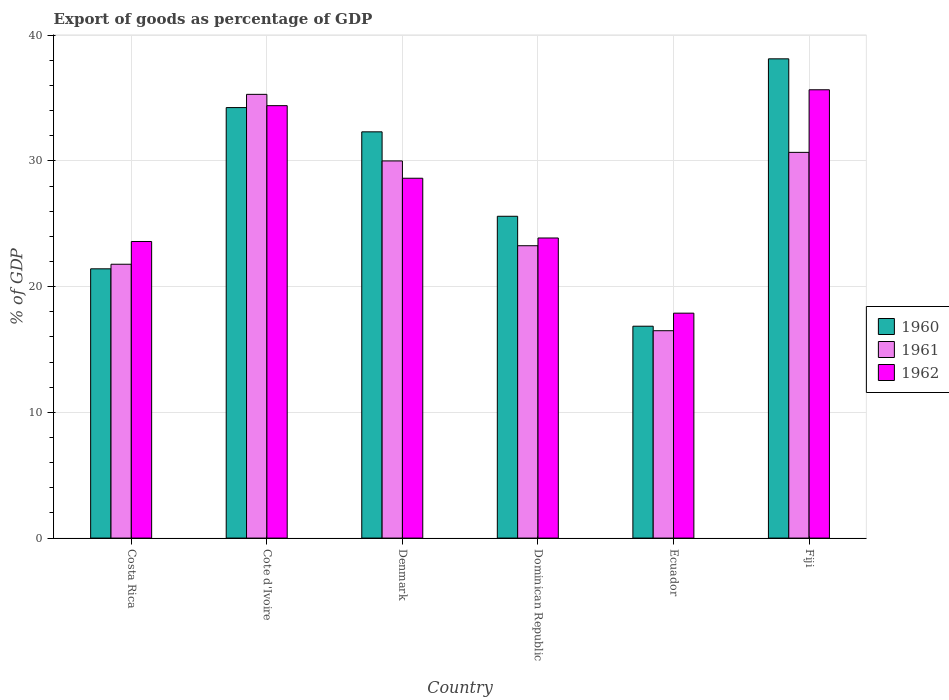How many different coloured bars are there?
Offer a very short reply. 3. Are the number of bars per tick equal to the number of legend labels?
Provide a short and direct response. Yes. Are the number of bars on each tick of the X-axis equal?
Offer a terse response. Yes. How many bars are there on the 4th tick from the left?
Offer a terse response. 3. How many bars are there on the 3rd tick from the right?
Give a very brief answer. 3. What is the label of the 4th group of bars from the left?
Your answer should be very brief. Dominican Republic. What is the export of goods as percentage of GDP in 1961 in Denmark?
Offer a very short reply. 30. Across all countries, what is the maximum export of goods as percentage of GDP in 1962?
Give a very brief answer. 35.66. Across all countries, what is the minimum export of goods as percentage of GDP in 1961?
Your response must be concise. 16.49. In which country was the export of goods as percentage of GDP in 1960 maximum?
Your answer should be very brief. Fiji. In which country was the export of goods as percentage of GDP in 1960 minimum?
Your answer should be compact. Ecuador. What is the total export of goods as percentage of GDP in 1961 in the graph?
Provide a short and direct response. 157.49. What is the difference between the export of goods as percentage of GDP in 1962 in Costa Rica and that in Dominican Republic?
Provide a succinct answer. -0.28. What is the difference between the export of goods as percentage of GDP in 1962 in Ecuador and the export of goods as percentage of GDP in 1961 in Dominican Republic?
Provide a short and direct response. -5.36. What is the average export of goods as percentage of GDP in 1961 per country?
Provide a short and direct response. 26.25. What is the difference between the export of goods as percentage of GDP of/in 1962 and export of goods as percentage of GDP of/in 1960 in Denmark?
Provide a succinct answer. -3.69. In how many countries, is the export of goods as percentage of GDP in 1961 greater than 28 %?
Keep it short and to the point. 3. What is the ratio of the export of goods as percentage of GDP in 1962 in Dominican Republic to that in Ecuador?
Give a very brief answer. 1.33. What is the difference between the highest and the second highest export of goods as percentage of GDP in 1960?
Provide a short and direct response. -1.93. What is the difference between the highest and the lowest export of goods as percentage of GDP in 1960?
Your answer should be very brief. 21.26. What does the 1st bar from the left in Ecuador represents?
Provide a short and direct response. 1960. What does the 1st bar from the right in Denmark represents?
Keep it short and to the point. 1962. Are all the bars in the graph horizontal?
Your answer should be very brief. No. How many countries are there in the graph?
Your response must be concise. 6. Are the values on the major ticks of Y-axis written in scientific E-notation?
Keep it short and to the point. No. Does the graph contain grids?
Offer a very short reply. Yes. Where does the legend appear in the graph?
Offer a very short reply. Center right. How are the legend labels stacked?
Your answer should be compact. Vertical. What is the title of the graph?
Offer a very short reply. Export of goods as percentage of GDP. What is the label or title of the X-axis?
Provide a short and direct response. Country. What is the label or title of the Y-axis?
Offer a terse response. % of GDP. What is the % of GDP of 1960 in Costa Rica?
Your response must be concise. 21.42. What is the % of GDP in 1961 in Costa Rica?
Provide a short and direct response. 21.78. What is the % of GDP in 1962 in Costa Rica?
Your answer should be very brief. 23.59. What is the % of GDP of 1960 in Cote d'Ivoire?
Your answer should be compact. 34.24. What is the % of GDP of 1961 in Cote d'Ivoire?
Keep it short and to the point. 35.29. What is the % of GDP of 1962 in Cote d'Ivoire?
Keep it short and to the point. 34.39. What is the % of GDP of 1960 in Denmark?
Your answer should be compact. 32.31. What is the % of GDP of 1961 in Denmark?
Offer a very short reply. 30. What is the % of GDP in 1962 in Denmark?
Make the answer very short. 28.62. What is the % of GDP of 1960 in Dominican Republic?
Offer a terse response. 25.59. What is the % of GDP of 1961 in Dominican Republic?
Provide a succinct answer. 23.25. What is the % of GDP in 1962 in Dominican Republic?
Your answer should be very brief. 23.87. What is the % of GDP in 1960 in Ecuador?
Offer a terse response. 16.85. What is the % of GDP of 1961 in Ecuador?
Keep it short and to the point. 16.49. What is the % of GDP of 1962 in Ecuador?
Your answer should be compact. 17.89. What is the % of GDP of 1960 in Fiji?
Give a very brief answer. 38.12. What is the % of GDP in 1961 in Fiji?
Your answer should be compact. 30.68. What is the % of GDP in 1962 in Fiji?
Provide a short and direct response. 35.66. Across all countries, what is the maximum % of GDP of 1960?
Make the answer very short. 38.12. Across all countries, what is the maximum % of GDP in 1961?
Your answer should be compact. 35.29. Across all countries, what is the maximum % of GDP in 1962?
Make the answer very short. 35.66. Across all countries, what is the minimum % of GDP in 1960?
Provide a short and direct response. 16.85. Across all countries, what is the minimum % of GDP in 1961?
Your answer should be compact. 16.49. Across all countries, what is the minimum % of GDP in 1962?
Offer a very short reply. 17.89. What is the total % of GDP in 1960 in the graph?
Your answer should be compact. 168.53. What is the total % of GDP in 1961 in the graph?
Your answer should be compact. 157.49. What is the total % of GDP of 1962 in the graph?
Offer a very short reply. 164.02. What is the difference between the % of GDP of 1960 in Costa Rica and that in Cote d'Ivoire?
Offer a terse response. -12.82. What is the difference between the % of GDP in 1961 in Costa Rica and that in Cote d'Ivoire?
Keep it short and to the point. -13.51. What is the difference between the % of GDP of 1962 in Costa Rica and that in Cote d'Ivoire?
Give a very brief answer. -10.8. What is the difference between the % of GDP in 1960 in Costa Rica and that in Denmark?
Provide a succinct answer. -10.89. What is the difference between the % of GDP in 1961 in Costa Rica and that in Denmark?
Keep it short and to the point. -8.22. What is the difference between the % of GDP of 1962 in Costa Rica and that in Denmark?
Offer a very short reply. -5.03. What is the difference between the % of GDP in 1960 in Costa Rica and that in Dominican Republic?
Provide a short and direct response. -4.18. What is the difference between the % of GDP of 1961 in Costa Rica and that in Dominican Republic?
Provide a short and direct response. -1.47. What is the difference between the % of GDP of 1962 in Costa Rica and that in Dominican Republic?
Provide a succinct answer. -0.28. What is the difference between the % of GDP in 1960 in Costa Rica and that in Ecuador?
Ensure brevity in your answer.  4.56. What is the difference between the % of GDP of 1961 in Costa Rica and that in Ecuador?
Offer a very short reply. 5.29. What is the difference between the % of GDP in 1962 in Costa Rica and that in Ecuador?
Provide a succinct answer. 5.7. What is the difference between the % of GDP in 1960 in Costa Rica and that in Fiji?
Give a very brief answer. -16.7. What is the difference between the % of GDP of 1961 in Costa Rica and that in Fiji?
Your answer should be very brief. -8.9. What is the difference between the % of GDP in 1962 in Costa Rica and that in Fiji?
Provide a succinct answer. -12.07. What is the difference between the % of GDP in 1960 in Cote d'Ivoire and that in Denmark?
Ensure brevity in your answer.  1.93. What is the difference between the % of GDP of 1961 in Cote d'Ivoire and that in Denmark?
Your response must be concise. 5.3. What is the difference between the % of GDP of 1962 in Cote d'Ivoire and that in Denmark?
Make the answer very short. 5.77. What is the difference between the % of GDP of 1960 in Cote d'Ivoire and that in Dominican Republic?
Your answer should be very brief. 8.64. What is the difference between the % of GDP in 1961 in Cote d'Ivoire and that in Dominican Republic?
Your answer should be compact. 12.04. What is the difference between the % of GDP in 1962 in Cote d'Ivoire and that in Dominican Republic?
Ensure brevity in your answer.  10.52. What is the difference between the % of GDP of 1960 in Cote d'Ivoire and that in Ecuador?
Offer a terse response. 17.39. What is the difference between the % of GDP of 1961 in Cote d'Ivoire and that in Ecuador?
Keep it short and to the point. 18.8. What is the difference between the % of GDP in 1962 in Cote d'Ivoire and that in Ecuador?
Offer a very short reply. 16.5. What is the difference between the % of GDP of 1960 in Cote d'Ivoire and that in Fiji?
Ensure brevity in your answer.  -3.88. What is the difference between the % of GDP in 1961 in Cote d'Ivoire and that in Fiji?
Your answer should be very brief. 4.61. What is the difference between the % of GDP in 1962 in Cote d'Ivoire and that in Fiji?
Give a very brief answer. -1.26. What is the difference between the % of GDP in 1960 in Denmark and that in Dominican Republic?
Provide a succinct answer. 6.72. What is the difference between the % of GDP in 1961 in Denmark and that in Dominican Republic?
Your answer should be very brief. 6.74. What is the difference between the % of GDP in 1962 in Denmark and that in Dominican Republic?
Ensure brevity in your answer.  4.75. What is the difference between the % of GDP in 1960 in Denmark and that in Ecuador?
Your answer should be compact. 15.46. What is the difference between the % of GDP of 1961 in Denmark and that in Ecuador?
Give a very brief answer. 13.5. What is the difference between the % of GDP in 1962 in Denmark and that in Ecuador?
Make the answer very short. 10.73. What is the difference between the % of GDP of 1960 in Denmark and that in Fiji?
Your response must be concise. -5.81. What is the difference between the % of GDP in 1961 in Denmark and that in Fiji?
Give a very brief answer. -0.68. What is the difference between the % of GDP in 1962 in Denmark and that in Fiji?
Offer a very short reply. -7.04. What is the difference between the % of GDP in 1960 in Dominican Republic and that in Ecuador?
Offer a terse response. 8.74. What is the difference between the % of GDP of 1961 in Dominican Republic and that in Ecuador?
Ensure brevity in your answer.  6.76. What is the difference between the % of GDP in 1962 in Dominican Republic and that in Ecuador?
Your response must be concise. 5.98. What is the difference between the % of GDP of 1960 in Dominican Republic and that in Fiji?
Ensure brevity in your answer.  -12.52. What is the difference between the % of GDP in 1961 in Dominican Republic and that in Fiji?
Offer a very short reply. -7.42. What is the difference between the % of GDP in 1962 in Dominican Republic and that in Fiji?
Ensure brevity in your answer.  -11.79. What is the difference between the % of GDP in 1960 in Ecuador and that in Fiji?
Offer a very short reply. -21.26. What is the difference between the % of GDP of 1961 in Ecuador and that in Fiji?
Keep it short and to the point. -14.18. What is the difference between the % of GDP in 1962 in Ecuador and that in Fiji?
Your answer should be very brief. -17.77. What is the difference between the % of GDP of 1960 in Costa Rica and the % of GDP of 1961 in Cote d'Ivoire?
Offer a terse response. -13.88. What is the difference between the % of GDP of 1960 in Costa Rica and the % of GDP of 1962 in Cote d'Ivoire?
Offer a terse response. -12.98. What is the difference between the % of GDP in 1961 in Costa Rica and the % of GDP in 1962 in Cote d'Ivoire?
Ensure brevity in your answer.  -12.61. What is the difference between the % of GDP of 1960 in Costa Rica and the % of GDP of 1961 in Denmark?
Offer a terse response. -8.58. What is the difference between the % of GDP in 1960 in Costa Rica and the % of GDP in 1962 in Denmark?
Provide a succinct answer. -7.2. What is the difference between the % of GDP in 1961 in Costa Rica and the % of GDP in 1962 in Denmark?
Offer a terse response. -6.84. What is the difference between the % of GDP of 1960 in Costa Rica and the % of GDP of 1961 in Dominican Republic?
Offer a terse response. -1.84. What is the difference between the % of GDP of 1960 in Costa Rica and the % of GDP of 1962 in Dominican Republic?
Provide a succinct answer. -2.45. What is the difference between the % of GDP in 1961 in Costa Rica and the % of GDP in 1962 in Dominican Republic?
Provide a short and direct response. -2.09. What is the difference between the % of GDP in 1960 in Costa Rica and the % of GDP in 1961 in Ecuador?
Your response must be concise. 4.92. What is the difference between the % of GDP of 1960 in Costa Rica and the % of GDP of 1962 in Ecuador?
Your answer should be compact. 3.53. What is the difference between the % of GDP in 1961 in Costa Rica and the % of GDP in 1962 in Ecuador?
Your answer should be compact. 3.89. What is the difference between the % of GDP of 1960 in Costa Rica and the % of GDP of 1961 in Fiji?
Offer a very short reply. -9.26. What is the difference between the % of GDP in 1960 in Costa Rica and the % of GDP in 1962 in Fiji?
Provide a short and direct response. -14.24. What is the difference between the % of GDP in 1961 in Costa Rica and the % of GDP in 1962 in Fiji?
Provide a succinct answer. -13.88. What is the difference between the % of GDP in 1960 in Cote d'Ivoire and the % of GDP in 1961 in Denmark?
Keep it short and to the point. 4.24. What is the difference between the % of GDP of 1960 in Cote d'Ivoire and the % of GDP of 1962 in Denmark?
Give a very brief answer. 5.62. What is the difference between the % of GDP in 1961 in Cote d'Ivoire and the % of GDP in 1962 in Denmark?
Your response must be concise. 6.67. What is the difference between the % of GDP of 1960 in Cote d'Ivoire and the % of GDP of 1961 in Dominican Republic?
Your response must be concise. 10.99. What is the difference between the % of GDP in 1960 in Cote d'Ivoire and the % of GDP in 1962 in Dominican Republic?
Ensure brevity in your answer.  10.37. What is the difference between the % of GDP of 1961 in Cote d'Ivoire and the % of GDP of 1962 in Dominican Republic?
Your answer should be very brief. 11.42. What is the difference between the % of GDP of 1960 in Cote d'Ivoire and the % of GDP of 1961 in Ecuador?
Your answer should be compact. 17.75. What is the difference between the % of GDP in 1960 in Cote d'Ivoire and the % of GDP in 1962 in Ecuador?
Provide a succinct answer. 16.35. What is the difference between the % of GDP of 1961 in Cote d'Ivoire and the % of GDP of 1962 in Ecuador?
Make the answer very short. 17.4. What is the difference between the % of GDP in 1960 in Cote d'Ivoire and the % of GDP in 1961 in Fiji?
Keep it short and to the point. 3.56. What is the difference between the % of GDP of 1960 in Cote d'Ivoire and the % of GDP of 1962 in Fiji?
Offer a very short reply. -1.42. What is the difference between the % of GDP in 1961 in Cote d'Ivoire and the % of GDP in 1962 in Fiji?
Provide a short and direct response. -0.36. What is the difference between the % of GDP of 1960 in Denmark and the % of GDP of 1961 in Dominican Republic?
Your response must be concise. 9.06. What is the difference between the % of GDP of 1960 in Denmark and the % of GDP of 1962 in Dominican Republic?
Your answer should be compact. 8.44. What is the difference between the % of GDP in 1961 in Denmark and the % of GDP in 1962 in Dominican Republic?
Ensure brevity in your answer.  6.13. What is the difference between the % of GDP of 1960 in Denmark and the % of GDP of 1961 in Ecuador?
Keep it short and to the point. 15.82. What is the difference between the % of GDP of 1960 in Denmark and the % of GDP of 1962 in Ecuador?
Make the answer very short. 14.42. What is the difference between the % of GDP of 1961 in Denmark and the % of GDP of 1962 in Ecuador?
Offer a very short reply. 12.11. What is the difference between the % of GDP of 1960 in Denmark and the % of GDP of 1961 in Fiji?
Offer a very short reply. 1.63. What is the difference between the % of GDP in 1960 in Denmark and the % of GDP in 1962 in Fiji?
Keep it short and to the point. -3.35. What is the difference between the % of GDP of 1961 in Denmark and the % of GDP of 1962 in Fiji?
Provide a short and direct response. -5.66. What is the difference between the % of GDP in 1960 in Dominican Republic and the % of GDP in 1961 in Ecuador?
Offer a very short reply. 9.1. What is the difference between the % of GDP in 1960 in Dominican Republic and the % of GDP in 1962 in Ecuador?
Your response must be concise. 7.71. What is the difference between the % of GDP in 1961 in Dominican Republic and the % of GDP in 1962 in Ecuador?
Your answer should be very brief. 5.36. What is the difference between the % of GDP in 1960 in Dominican Republic and the % of GDP in 1961 in Fiji?
Your answer should be very brief. -5.08. What is the difference between the % of GDP in 1960 in Dominican Republic and the % of GDP in 1962 in Fiji?
Make the answer very short. -10.06. What is the difference between the % of GDP in 1961 in Dominican Republic and the % of GDP in 1962 in Fiji?
Your answer should be compact. -12.4. What is the difference between the % of GDP of 1960 in Ecuador and the % of GDP of 1961 in Fiji?
Keep it short and to the point. -13.83. What is the difference between the % of GDP in 1960 in Ecuador and the % of GDP in 1962 in Fiji?
Ensure brevity in your answer.  -18.8. What is the difference between the % of GDP of 1961 in Ecuador and the % of GDP of 1962 in Fiji?
Keep it short and to the point. -19.16. What is the average % of GDP of 1960 per country?
Offer a very short reply. 28.09. What is the average % of GDP in 1961 per country?
Your response must be concise. 26.25. What is the average % of GDP of 1962 per country?
Ensure brevity in your answer.  27.34. What is the difference between the % of GDP of 1960 and % of GDP of 1961 in Costa Rica?
Provide a short and direct response. -0.36. What is the difference between the % of GDP in 1960 and % of GDP in 1962 in Costa Rica?
Provide a succinct answer. -2.17. What is the difference between the % of GDP of 1961 and % of GDP of 1962 in Costa Rica?
Your answer should be compact. -1.81. What is the difference between the % of GDP in 1960 and % of GDP in 1961 in Cote d'Ivoire?
Your answer should be compact. -1.05. What is the difference between the % of GDP of 1960 and % of GDP of 1962 in Cote d'Ivoire?
Make the answer very short. -0.15. What is the difference between the % of GDP in 1961 and % of GDP in 1962 in Cote d'Ivoire?
Your answer should be very brief. 0.9. What is the difference between the % of GDP in 1960 and % of GDP in 1961 in Denmark?
Give a very brief answer. 2.31. What is the difference between the % of GDP in 1960 and % of GDP in 1962 in Denmark?
Offer a very short reply. 3.69. What is the difference between the % of GDP of 1961 and % of GDP of 1962 in Denmark?
Your answer should be very brief. 1.38. What is the difference between the % of GDP in 1960 and % of GDP in 1961 in Dominican Republic?
Make the answer very short. 2.34. What is the difference between the % of GDP in 1960 and % of GDP in 1962 in Dominican Republic?
Keep it short and to the point. 1.73. What is the difference between the % of GDP in 1961 and % of GDP in 1962 in Dominican Republic?
Offer a terse response. -0.62. What is the difference between the % of GDP in 1960 and % of GDP in 1961 in Ecuador?
Ensure brevity in your answer.  0.36. What is the difference between the % of GDP of 1960 and % of GDP of 1962 in Ecuador?
Make the answer very short. -1.04. What is the difference between the % of GDP in 1961 and % of GDP in 1962 in Ecuador?
Ensure brevity in your answer.  -1.4. What is the difference between the % of GDP of 1960 and % of GDP of 1961 in Fiji?
Provide a short and direct response. 7.44. What is the difference between the % of GDP of 1960 and % of GDP of 1962 in Fiji?
Provide a short and direct response. 2.46. What is the difference between the % of GDP in 1961 and % of GDP in 1962 in Fiji?
Provide a short and direct response. -4.98. What is the ratio of the % of GDP in 1960 in Costa Rica to that in Cote d'Ivoire?
Make the answer very short. 0.63. What is the ratio of the % of GDP of 1961 in Costa Rica to that in Cote d'Ivoire?
Offer a terse response. 0.62. What is the ratio of the % of GDP of 1962 in Costa Rica to that in Cote d'Ivoire?
Your response must be concise. 0.69. What is the ratio of the % of GDP of 1960 in Costa Rica to that in Denmark?
Your response must be concise. 0.66. What is the ratio of the % of GDP in 1961 in Costa Rica to that in Denmark?
Offer a terse response. 0.73. What is the ratio of the % of GDP of 1962 in Costa Rica to that in Denmark?
Your answer should be very brief. 0.82. What is the ratio of the % of GDP in 1960 in Costa Rica to that in Dominican Republic?
Your answer should be very brief. 0.84. What is the ratio of the % of GDP in 1961 in Costa Rica to that in Dominican Republic?
Make the answer very short. 0.94. What is the ratio of the % of GDP in 1962 in Costa Rica to that in Dominican Republic?
Your answer should be compact. 0.99. What is the ratio of the % of GDP in 1960 in Costa Rica to that in Ecuador?
Give a very brief answer. 1.27. What is the ratio of the % of GDP of 1961 in Costa Rica to that in Ecuador?
Provide a succinct answer. 1.32. What is the ratio of the % of GDP in 1962 in Costa Rica to that in Ecuador?
Offer a terse response. 1.32. What is the ratio of the % of GDP of 1960 in Costa Rica to that in Fiji?
Give a very brief answer. 0.56. What is the ratio of the % of GDP of 1961 in Costa Rica to that in Fiji?
Give a very brief answer. 0.71. What is the ratio of the % of GDP in 1962 in Costa Rica to that in Fiji?
Provide a succinct answer. 0.66. What is the ratio of the % of GDP in 1960 in Cote d'Ivoire to that in Denmark?
Offer a terse response. 1.06. What is the ratio of the % of GDP of 1961 in Cote d'Ivoire to that in Denmark?
Your answer should be compact. 1.18. What is the ratio of the % of GDP of 1962 in Cote d'Ivoire to that in Denmark?
Ensure brevity in your answer.  1.2. What is the ratio of the % of GDP of 1960 in Cote d'Ivoire to that in Dominican Republic?
Keep it short and to the point. 1.34. What is the ratio of the % of GDP in 1961 in Cote d'Ivoire to that in Dominican Republic?
Offer a very short reply. 1.52. What is the ratio of the % of GDP of 1962 in Cote d'Ivoire to that in Dominican Republic?
Give a very brief answer. 1.44. What is the ratio of the % of GDP in 1960 in Cote d'Ivoire to that in Ecuador?
Your response must be concise. 2.03. What is the ratio of the % of GDP of 1961 in Cote d'Ivoire to that in Ecuador?
Your response must be concise. 2.14. What is the ratio of the % of GDP of 1962 in Cote d'Ivoire to that in Ecuador?
Provide a succinct answer. 1.92. What is the ratio of the % of GDP in 1960 in Cote d'Ivoire to that in Fiji?
Offer a very short reply. 0.9. What is the ratio of the % of GDP of 1961 in Cote d'Ivoire to that in Fiji?
Offer a very short reply. 1.15. What is the ratio of the % of GDP of 1962 in Cote d'Ivoire to that in Fiji?
Your answer should be compact. 0.96. What is the ratio of the % of GDP of 1960 in Denmark to that in Dominican Republic?
Your answer should be very brief. 1.26. What is the ratio of the % of GDP of 1961 in Denmark to that in Dominican Republic?
Your answer should be compact. 1.29. What is the ratio of the % of GDP in 1962 in Denmark to that in Dominican Republic?
Offer a terse response. 1.2. What is the ratio of the % of GDP in 1960 in Denmark to that in Ecuador?
Your answer should be compact. 1.92. What is the ratio of the % of GDP in 1961 in Denmark to that in Ecuador?
Your response must be concise. 1.82. What is the ratio of the % of GDP in 1962 in Denmark to that in Ecuador?
Your answer should be compact. 1.6. What is the ratio of the % of GDP in 1960 in Denmark to that in Fiji?
Provide a succinct answer. 0.85. What is the ratio of the % of GDP of 1961 in Denmark to that in Fiji?
Give a very brief answer. 0.98. What is the ratio of the % of GDP of 1962 in Denmark to that in Fiji?
Keep it short and to the point. 0.8. What is the ratio of the % of GDP of 1960 in Dominican Republic to that in Ecuador?
Provide a short and direct response. 1.52. What is the ratio of the % of GDP in 1961 in Dominican Republic to that in Ecuador?
Provide a succinct answer. 1.41. What is the ratio of the % of GDP in 1962 in Dominican Republic to that in Ecuador?
Offer a very short reply. 1.33. What is the ratio of the % of GDP of 1960 in Dominican Republic to that in Fiji?
Your answer should be compact. 0.67. What is the ratio of the % of GDP in 1961 in Dominican Republic to that in Fiji?
Your answer should be very brief. 0.76. What is the ratio of the % of GDP in 1962 in Dominican Republic to that in Fiji?
Your response must be concise. 0.67. What is the ratio of the % of GDP of 1960 in Ecuador to that in Fiji?
Keep it short and to the point. 0.44. What is the ratio of the % of GDP of 1961 in Ecuador to that in Fiji?
Offer a terse response. 0.54. What is the ratio of the % of GDP in 1962 in Ecuador to that in Fiji?
Offer a very short reply. 0.5. What is the difference between the highest and the second highest % of GDP of 1960?
Ensure brevity in your answer.  3.88. What is the difference between the highest and the second highest % of GDP of 1961?
Your response must be concise. 4.61. What is the difference between the highest and the second highest % of GDP of 1962?
Your answer should be very brief. 1.26. What is the difference between the highest and the lowest % of GDP in 1960?
Your answer should be very brief. 21.26. What is the difference between the highest and the lowest % of GDP of 1961?
Offer a very short reply. 18.8. What is the difference between the highest and the lowest % of GDP in 1962?
Provide a succinct answer. 17.77. 